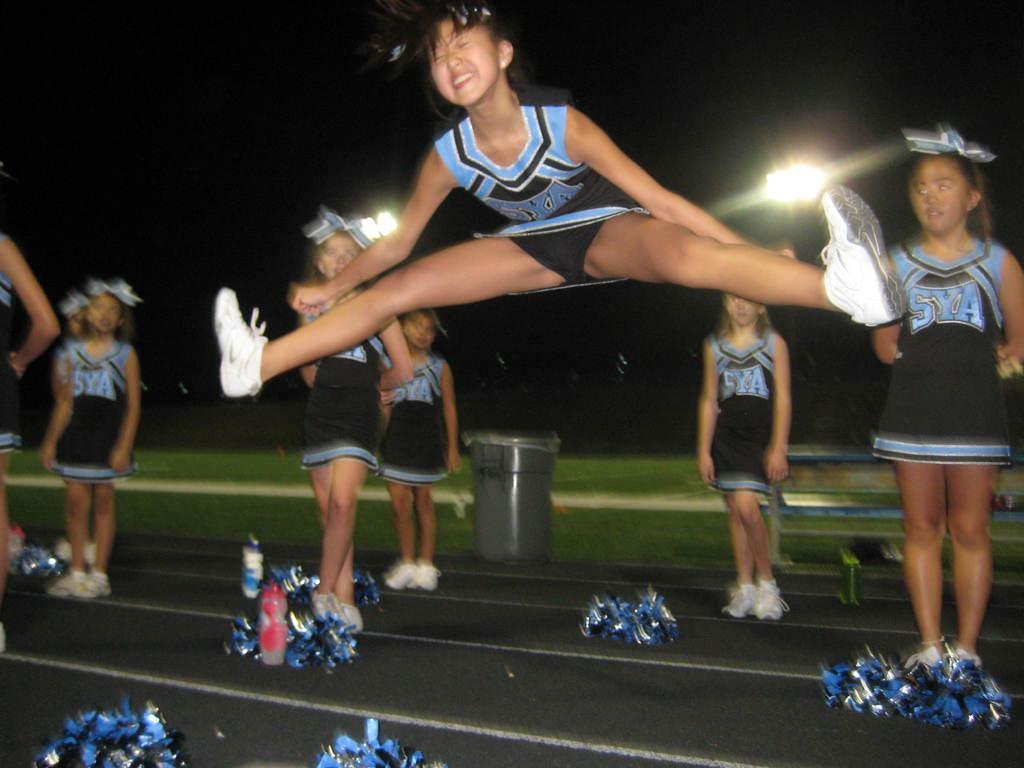What are the initials of the cheerleader's school?
Offer a very short reply. Sya. 